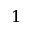<formula> <loc_0><loc_0><loc_500><loc_500>1</formula> 